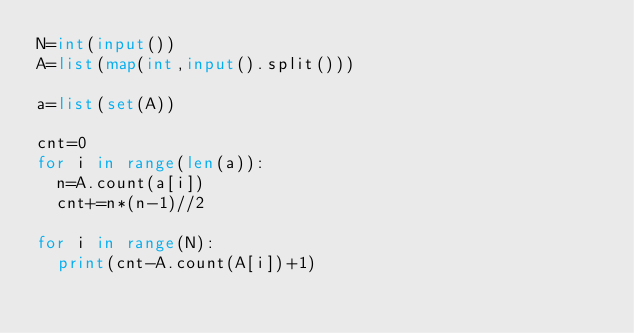Convert code to text. <code><loc_0><loc_0><loc_500><loc_500><_Python_>N=int(input())
A=list(map(int,input().split()))

a=list(set(A))

cnt=0
for i in range(len(a)):
  n=A.count(a[i])
  cnt+=n*(n-1)//2

for i in range(N):
  print(cnt-A.count(A[i])+1)</code> 